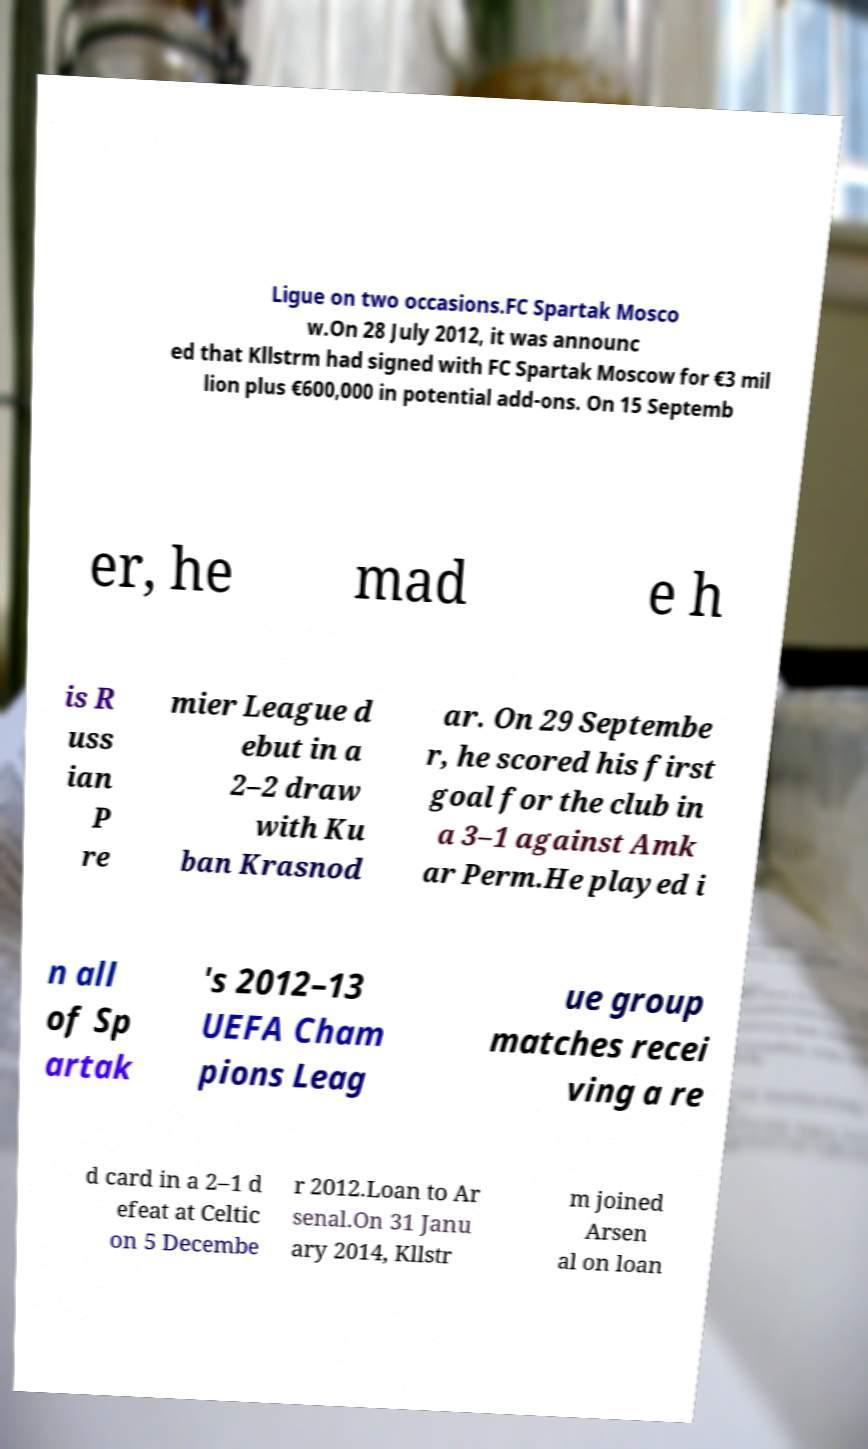Could you extract and type out the text from this image? Ligue on two occasions.FC Spartak Mosco w.On 28 July 2012, it was announc ed that Kllstrm had signed with FC Spartak Moscow for €3 mil lion plus €600,000 in potential add-ons. On 15 Septemb er, he mad e h is R uss ian P re mier League d ebut in a 2–2 draw with Ku ban Krasnod ar. On 29 Septembe r, he scored his first goal for the club in a 3–1 against Amk ar Perm.He played i n all of Sp artak 's 2012–13 UEFA Cham pions Leag ue group matches recei ving a re d card in a 2–1 d efeat at Celtic on 5 Decembe r 2012.Loan to Ar senal.On 31 Janu ary 2014, Kllstr m joined Arsen al on loan 